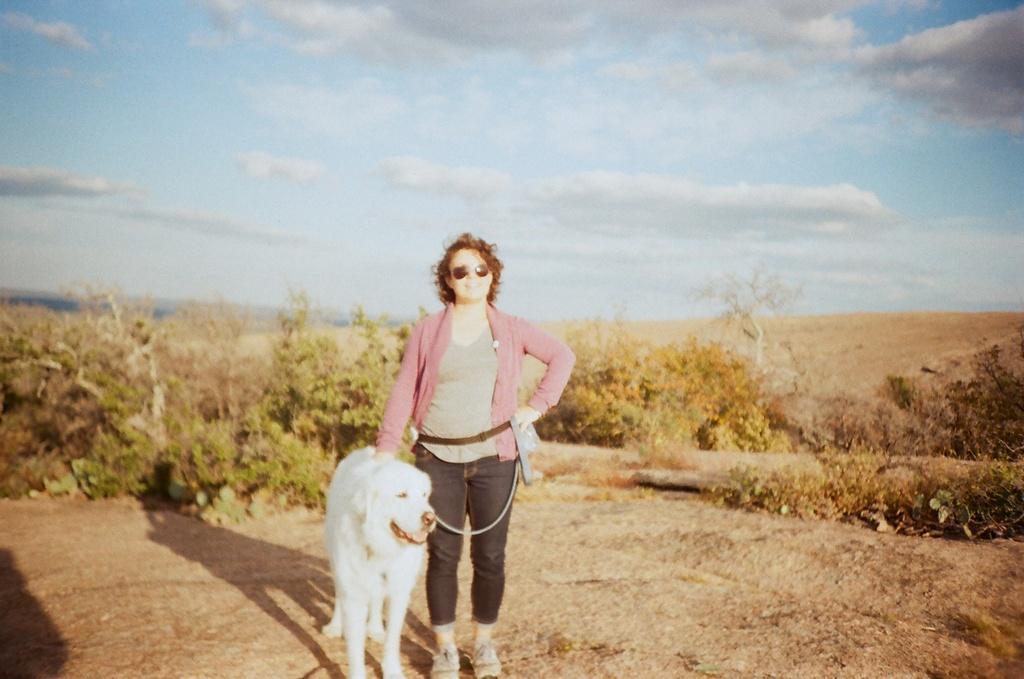In one or two sentences, can you explain what this image depicts? In this image i can see a woman standing and holding the dogs belt, at the back ground i can see a tree and a sky. 